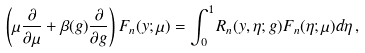<formula> <loc_0><loc_0><loc_500><loc_500>\left ( \mu \frac { \partial } { \partial \mu } + \beta ( g ) \frac { \partial } { \partial g } \right ) F _ { n } ( y ; \mu ) = \int _ { 0 } ^ { 1 } R _ { n } ( y , \eta ; g ) F _ { n } ( \eta ; \mu ) d \eta \, ,</formula> 